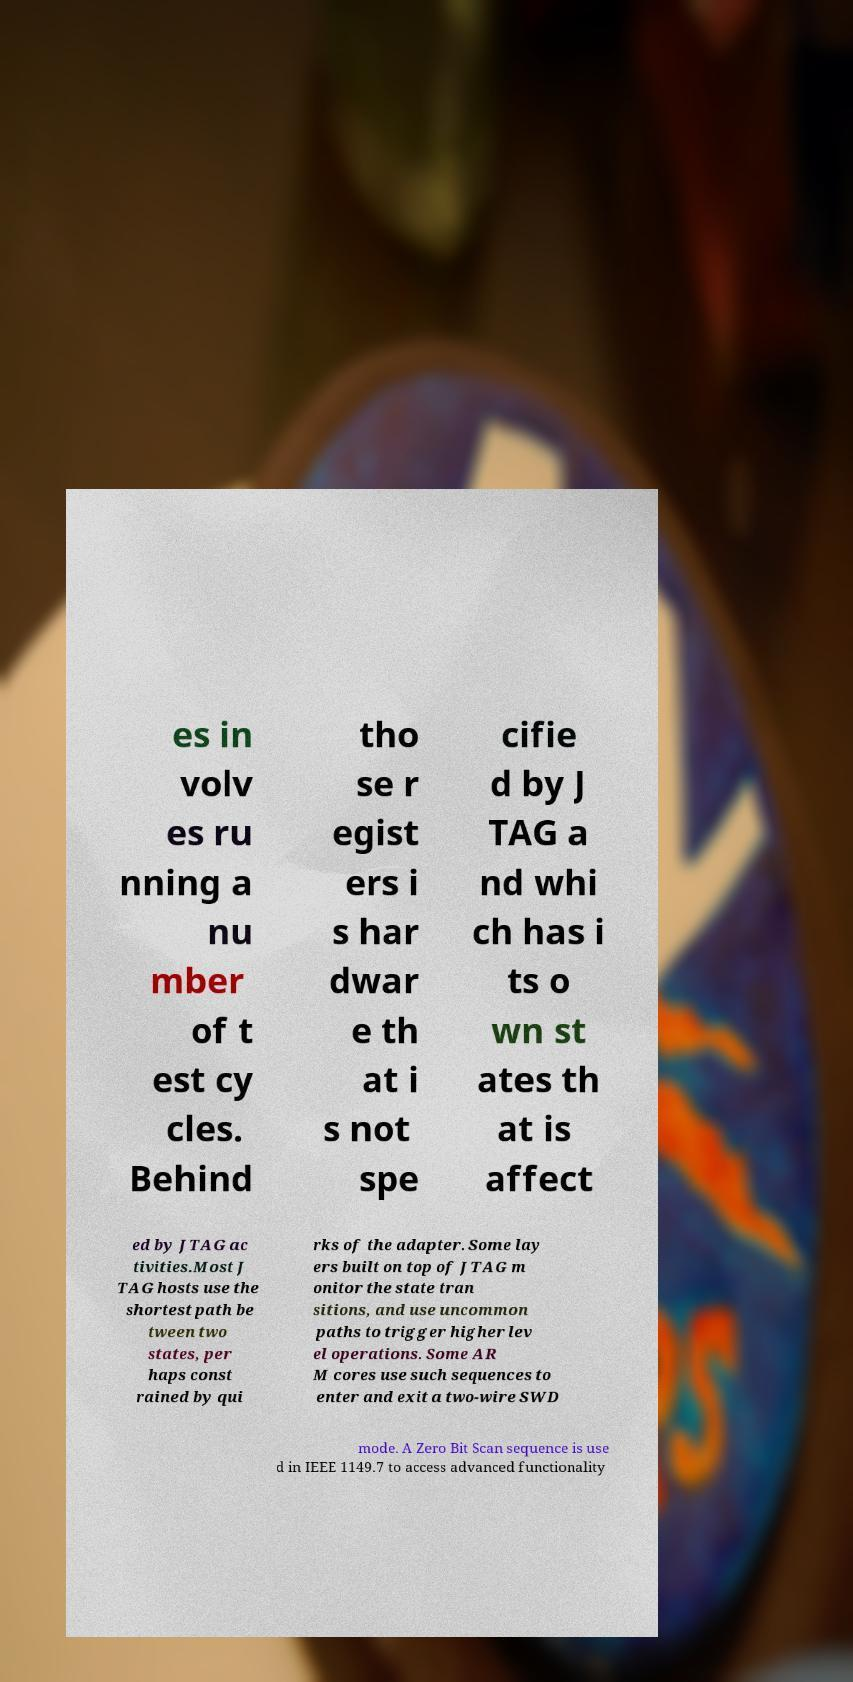There's text embedded in this image that I need extracted. Can you transcribe it verbatim? es in volv es ru nning a nu mber of t est cy cles. Behind tho se r egist ers i s har dwar e th at i s not spe cifie d by J TAG a nd whi ch has i ts o wn st ates th at is affect ed by JTAG ac tivities.Most J TAG hosts use the shortest path be tween two states, per haps const rained by qui rks of the adapter. Some lay ers built on top of JTAG m onitor the state tran sitions, and use uncommon paths to trigger higher lev el operations. Some AR M cores use such sequences to enter and exit a two-wire SWD mode. A Zero Bit Scan sequence is use d in IEEE 1149.7 to access advanced functionality 